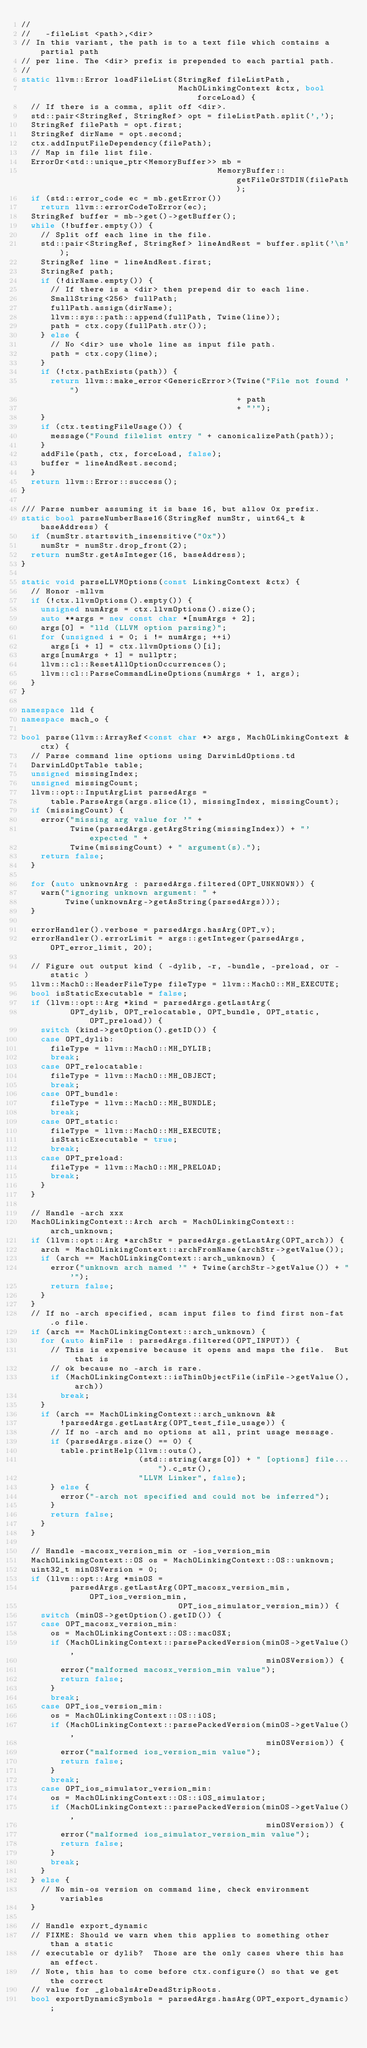Convert code to text. <code><loc_0><loc_0><loc_500><loc_500><_C++_>//
//   -fileList <path>,<dir>
// In this variant, the path is to a text file which contains a partial path
// per line. The <dir> prefix is prepended to each partial path.
//
static llvm::Error loadFileList(StringRef fileListPath,
                                MachOLinkingContext &ctx, bool forceLoad) {
  // If there is a comma, split off <dir>.
  std::pair<StringRef, StringRef> opt = fileListPath.split(',');
  StringRef filePath = opt.first;
  StringRef dirName = opt.second;
  ctx.addInputFileDependency(filePath);
  // Map in file list file.
  ErrorOr<std::unique_ptr<MemoryBuffer>> mb =
                                        MemoryBuffer::getFileOrSTDIN(filePath);
  if (std::error_code ec = mb.getError())
    return llvm::errorCodeToError(ec);
  StringRef buffer = mb->get()->getBuffer();
  while (!buffer.empty()) {
    // Split off each line in the file.
    std::pair<StringRef, StringRef> lineAndRest = buffer.split('\n');
    StringRef line = lineAndRest.first;
    StringRef path;
    if (!dirName.empty()) {
      // If there is a <dir> then prepend dir to each line.
      SmallString<256> fullPath;
      fullPath.assign(dirName);
      llvm::sys::path::append(fullPath, Twine(line));
      path = ctx.copy(fullPath.str());
    } else {
      // No <dir> use whole line as input file path.
      path = ctx.copy(line);
    }
    if (!ctx.pathExists(path)) {
      return llvm::make_error<GenericError>(Twine("File not found '")
                                            + path
                                            + "'");
    }
    if (ctx.testingFileUsage()) {
      message("Found filelist entry " + canonicalizePath(path));
    }
    addFile(path, ctx, forceLoad, false);
    buffer = lineAndRest.second;
  }
  return llvm::Error::success();
}

/// Parse number assuming it is base 16, but allow 0x prefix.
static bool parseNumberBase16(StringRef numStr, uint64_t &baseAddress) {
  if (numStr.startswith_insensitive("0x"))
    numStr = numStr.drop_front(2);
  return numStr.getAsInteger(16, baseAddress);
}

static void parseLLVMOptions(const LinkingContext &ctx) {
  // Honor -mllvm
  if (!ctx.llvmOptions().empty()) {
    unsigned numArgs = ctx.llvmOptions().size();
    auto **args = new const char *[numArgs + 2];
    args[0] = "lld (LLVM option parsing)";
    for (unsigned i = 0; i != numArgs; ++i)
      args[i + 1] = ctx.llvmOptions()[i];
    args[numArgs + 1] = nullptr;
    llvm::cl::ResetAllOptionOccurrences();
    llvm::cl::ParseCommandLineOptions(numArgs + 1, args);
  }
}

namespace lld {
namespace mach_o {

bool parse(llvm::ArrayRef<const char *> args, MachOLinkingContext &ctx) {
  // Parse command line options using DarwinLdOptions.td
  DarwinLdOptTable table;
  unsigned missingIndex;
  unsigned missingCount;
  llvm::opt::InputArgList parsedArgs =
      table.ParseArgs(args.slice(1), missingIndex, missingCount);
  if (missingCount) {
    error("missing arg value for '" +
          Twine(parsedArgs.getArgString(missingIndex)) + "' expected " +
          Twine(missingCount) + " argument(s).");
    return false;
  }

  for (auto unknownArg : parsedArgs.filtered(OPT_UNKNOWN)) {
    warn("ignoring unknown argument: " +
         Twine(unknownArg->getAsString(parsedArgs)));
  }

  errorHandler().verbose = parsedArgs.hasArg(OPT_v);
  errorHandler().errorLimit = args::getInteger(parsedArgs, OPT_error_limit, 20);

  // Figure out output kind ( -dylib, -r, -bundle, -preload, or -static )
  llvm::MachO::HeaderFileType fileType = llvm::MachO::MH_EXECUTE;
  bool isStaticExecutable = false;
  if (llvm::opt::Arg *kind = parsedArgs.getLastArg(
          OPT_dylib, OPT_relocatable, OPT_bundle, OPT_static, OPT_preload)) {
    switch (kind->getOption().getID()) {
    case OPT_dylib:
      fileType = llvm::MachO::MH_DYLIB;
      break;
    case OPT_relocatable:
      fileType = llvm::MachO::MH_OBJECT;
      break;
    case OPT_bundle:
      fileType = llvm::MachO::MH_BUNDLE;
      break;
    case OPT_static:
      fileType = llvm::MachO::MH_EXECUTE;
      isStaticExecutable = true;
      break;
    case OPT_preload:
      fileType = llvm::MachO::MH_PRELOAD;
      break;
    }
  }

  // Handle -arch xxx
  MachOLinkingContext::Arch arch = MachOLinkingContext::arch_unknown;
  if (llvm::opt::Arg *archStr = parsedArgs.getLastArg(OPT_arch)) {
    arch = MachOLinkingContext::archFromName(archStr->getValue());
    if (arch == MachOLinkingContext::arch_unknown) {
      error("unknown arch named '" + Twine(archStr->getValue()) + "'");
      return false;
    }
  }
  // If no -arch specified, scan input files to find first non-fat .o file.
  if (arch == MachOLinkingContext::arch_unknown) {
    for (auto &inFile : parsedArgs.filtered(OPT_INPUT)) {
      // This is expensive because it opens and maps the file.  But that is
      // ok because no -arch is rare.
      if (MachOLinkingContext::isThinObjectFile(inFile->getValue(), arch))
        break;
    }
    if (arch == MachOLinkingContext::arch_unknown &&
        !parsedArgs.getLastArg(OPT_test_file_usage)) {
      // If no -arch and no options at all, print usage message.
      if (parsedArgs.size() == 0) {
        table.printHelp(llvm::outs(),
                        (std::string(args[0]) + " [options] file...").c_str(),
                        "LLVM Linker", false);
      } else {
        error("-arch not specified and could not be inferred");
      }
      return false;
    }
  }

  // Handle -macosx_version_min or -ios_version_min
  MachOLinkingContext::OS os = MachOLinkingContext::OS::unknown;
  uint32_t minOSVersion = 0;
  if (llvm::opt::Arg *minOS =
          parsedArgs.getLastArg(OPT_macosx_version_min, OPT_ios_version_min,
                                OPT_ios_simulator_version_min)) {
    switch (minOS->getOption().getID()) {
    case OPT_macosx_version_min:
      os = MachOLinkingContext::OS::macOSX;
      if (MachOLinkingContext::parsePackedVersion(minOS->getValue(),
                                                  minOSVersion)) {
        error("malformed macosx_version_min value");
        return false;
      }
      break;
    case OPT_ios_version_min:
      os = MachOLinkingContext::OS::iOS;
      if (MachOLinkingContext::parsePackedVersion(minOS->getValue(),
                                                  minOSVersion)) {
        error("malformed ios_version_min value");
        return false;
      }
      break;
    case OPT_ios_simulator_version_min:
      os = MachOLinkingContext::OS::iOS_simulator;
      if (MachOLinkingContext::parsePackedVersion(minOS->getValue(),
                                                  minOSVersion)) {
        error("malformed ios_simulator_version_min value");
        return false;
      }
      break;
    }
  } else {
    // No min-os version on command line, check environment variables
  }

  // Handle export_dynamic
  // FIXME: Should we warn when this applies to something other than a static
  // executable or dylib?  Those are the only cases where this has an effect.
  // Note, this has to come before ctx.configure() so that we get the correct
  // value for _globalsAreDeadStripRoots.
  bool exportDynamicSymbols = parsedArgs.hasArg(OPT_export_dynamic);
</code> 